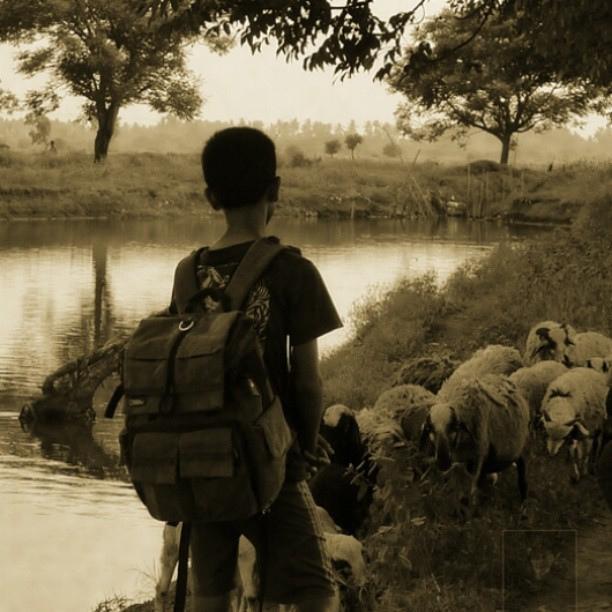How many sheep are visible?
Give a very brief answer. 5. How many zebras are there?
Give a very brief answer. 0. 